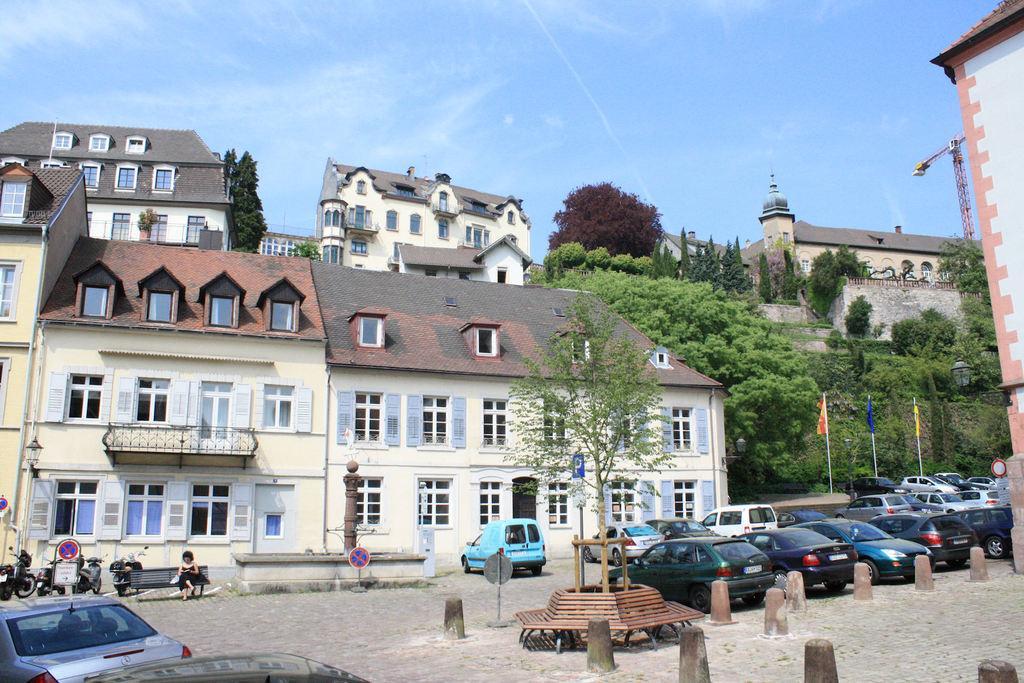In one or two sentences, can you explain what this image depicts? In this image I can see number of cars parked in the street, a bench, few poles, a tree, building, a woman sitting on the bench, few motorbikes, few sign boards and few Windows of the building. In the background I can see few trees, a crane and the sky. 